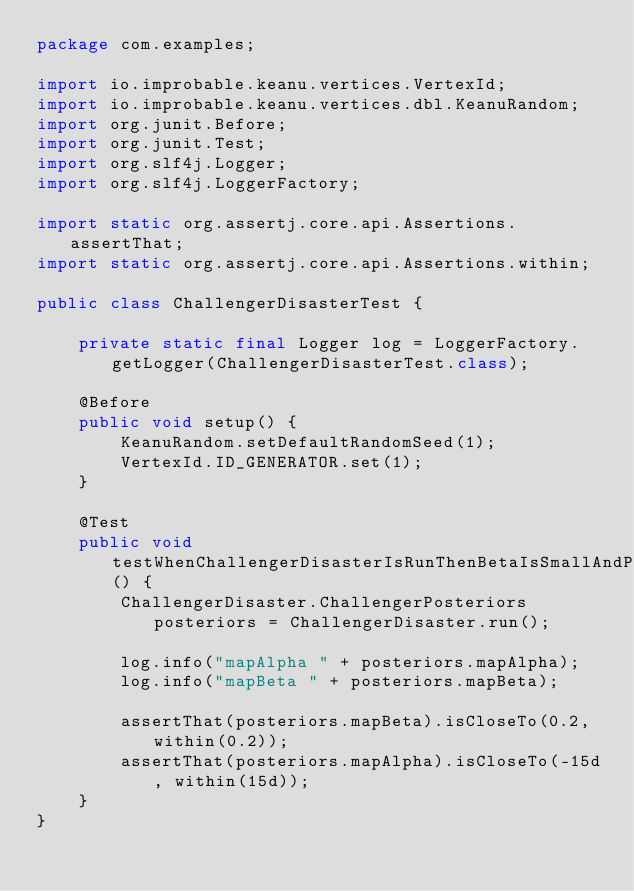<code> <loc_0><loc_0><loc_500><loc_500><_Java_>package com.examples;

import io.improbable.keanu.vertices.VertexId;
import io.improbable.keanu.vertices.dbl.KeanuRandom;
import org.junit.Before;
import org.junit.Test;
import org.slf4j.Logger;
import org.slf4j.LoggerFactory;

import static org.assertj.core.api.Assertions.assertThat;
import static org.assertj.core.api.Assertions.within;

public class ChallengerDisasterTest {

    private static final Logger log = LoggerFactory.getLogger(ChallengerDisasterTest.class);

    @Before
    public void setup() {
        KeanuRandom.setDefaultRandomSeed(1);
        VertexId.ID_GENERATOR.set(1);
    }

    @Test
    public void testWhenChallengerDisasterIsRunThenBetaIsSmallAndPositive() {
        ChallengerDisaster.ChallengerPosteriors posteriors = ChallengerDisaster.run();

        log.info("mapAlpha " + posteriors.mapAlpha);
        log.info("mapBeta " + posteriors.mapBeta);

        assertThat(posteriors.mapBeta).isCloseTo(0.2, within(0.2));
        assertThat(posteriors.mapAlpha).isCloseTo(-15d, within(15d));
    }
}
</code> 